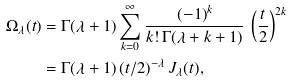Convert formula to latex. <formula><loc_0><loc_0><loc_500><loc_500>\Omega _ { \lambda } ( t ) & = \Gamma ( \lambda + 1 ) \sum _ { k = 0 } ^ { \infty } \frac { ( - 1 ) ^ { k } } { k ! \, \Gamma ( \lambda + k + 1 ) } \, \left ( \frac { t } { 2 } \right ) ^ { 2 k } \\ & = \Gamma ( \lambda + 1 ) \left ( t / 2 \right ) ^ { - \lambda } J _ { \lambda } ( t ) ,</formula> 